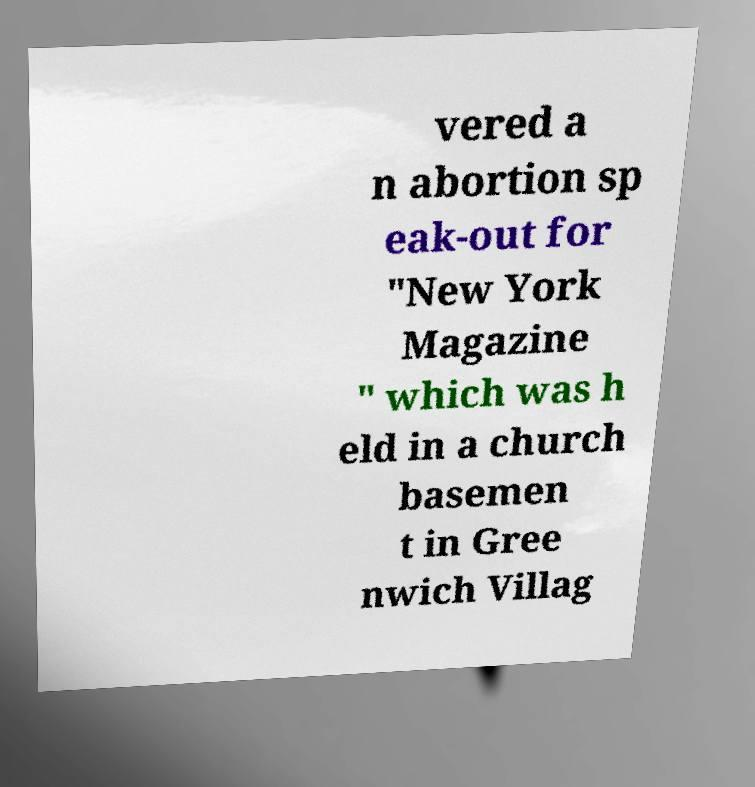There's text embedded in this image that I need extracted. Can you transcribe it verbatim? vered a n abortion sp eak-out for "New York Magazine " which was h eld in a church basemen t in Gree nwich Villag 